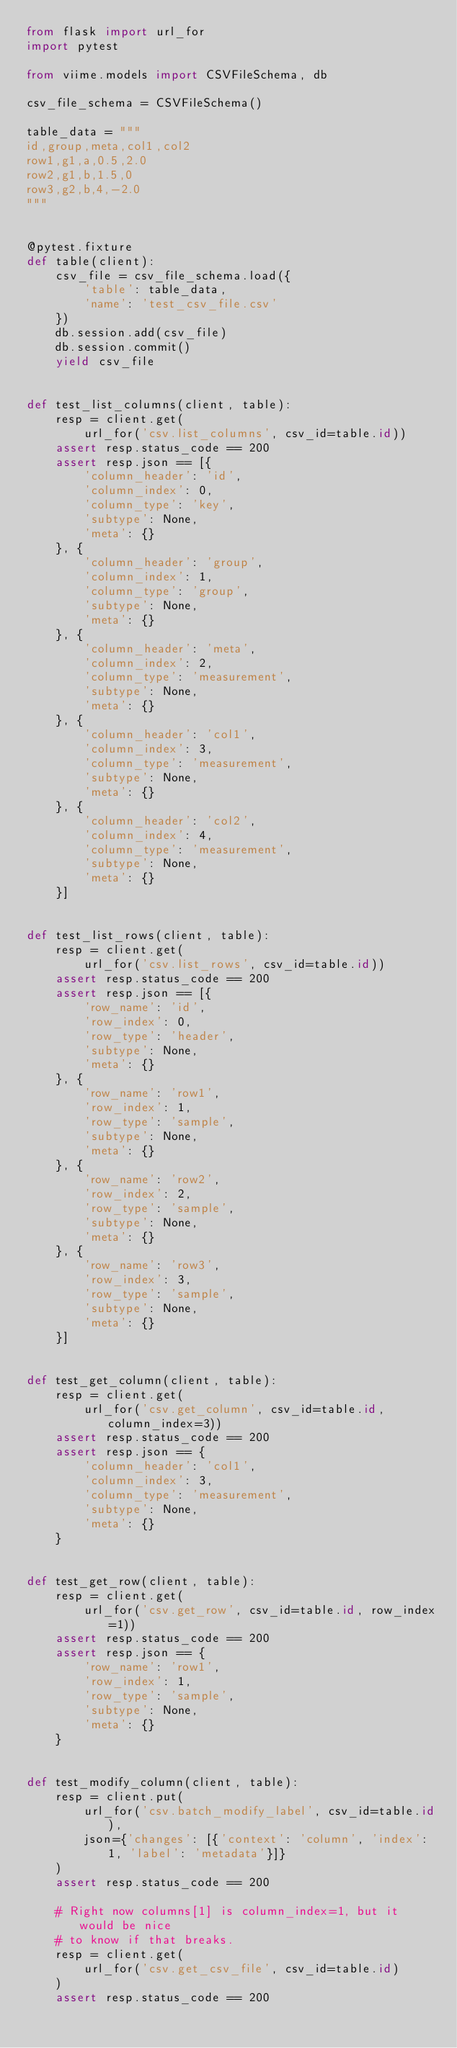Convert code to text. <code><loc_0><loc_0><loc_500><loc_500><_Python_>from flask import url_for
import pytest

from viime.models import CSVFileSchema, db

csv_file_schema = CSVFileSchema()

table_data = """
id,group,meta,col1,col2
row1,g1,a,0.5,2.0
row2,g1,b,1.5,0
row3,g2,b,4,-2.0
"""


@pytest.fixture
def table(client):
    csv_file = csv_file_schema.load({
        'table': table_data,
        'name': 'test_csv_file.csv'
    })
    db.session.add(csv_file)
    db.session.commit()
    yield csv_file


def test_list_columns(client, table):
    resp = client.get(
        url_for('csv.list_columns', csv_id=table.id))
    assert resp.status_code == 200
    assert resp.json == [{
        'column_header': 'id',
        'column_index': 0,
        'column_type': 'key',
        'subtype': None,
        'meta': {}
    }, {
        'column_header': 'group',
        'column_index': 1,
        'column_type': 'group',
        'subtype': None,
        'meta': {}
    }, {
        'column_header': 'meta',
        'column_index': 2,
        'column_type': 'measurement',
        'subtype': None,
        'meta': {}
    }, {
        'column_header': 'col1',
        'column_index': 3,
        'column_type': 'measurement',
        'subtype': None,
        'meta': {}
    }, {
        'column_header': 'col2',
        'column_index': 4,
        'column_type': 'measurement',
        'subtype': None,
        'meta': {}
    }]


def test_list_rows(client, table):
    resp = client.get(
        url_for('csv.list_rows', csv_id=table.id))
    assert resp.status_code == 200
    assert resp.json == [{
        'row_name': 'id',
        'row_index': 0,
        'row_type': 'header',
        'subtype': None,
        'meta': {}
    }, {
        'row_name': 'row1',
        'row_index': 1,
        'row_type': 'sample',
        'subtype': None,
        'meta': {}
    }, {
        'row_name': 'row2',
        'row_index': 2,
        'row_type': 'sample',
        'subtype': None,
        'meta': {}
    }, {
        'row_name': 'row3',
        'row_index': 3,
        'row_type': 'sample',
        'subtype': None,
        'meta': {}
    }]


def test_get_column(client, table):
    resp = client.get(
        url_for('csv.get_column', csv_id=table.id, column_index=3))
    assert resp.status_code == 200
    assert resp.json == {
        'column_header': 'col1',
        'column_index': 3,
        'column_type': 'measurement',
        'subtype': None,
        'meta': {}
    }


def test_get_row(client, table):
    resp = client.get(
        url_for('csv.get_row', csv_id=table.id, row_index=1))
    assert resp.status_code == 200
    assert resp.json == {
        'row_name': 'row1',
        'row_index': 1,
        'row_type': 'sample',
        'subtype': None,
        'meta': {}
    }


def test_modify_column(client, table):
    resp = client.put(
        url_for('csv.batch_modify_label', csv_id=table.id),
        json={'changes': [{'context': 'column', 'index': 1, 'label': 'metadata'}]}
    )
    assert resp.status_code == 200

    # Right now columns[1] is column_index=1, but it would be nice
    # to know if that breaks.
    resp = client.get(
        url_for('csv.get_csv_file', csv_id=table.id)
    )
    assert resp.status_code == 200</code> 